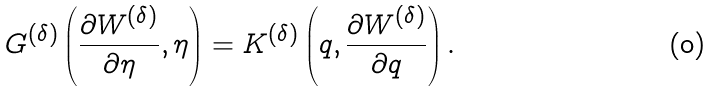<formula> <loc_0><loc_0><loc_500><loc_500>G ^ { ( \delta ) } \left ( \frac { \partial W ^ { ( \delta ) } } { \partial \eta } , \eta \right ) = K ^ { ( \delta ) } \left ( q , \frac { \partial W ^ { ( \delta ) } } { \partial q } \right ) .</formula> 